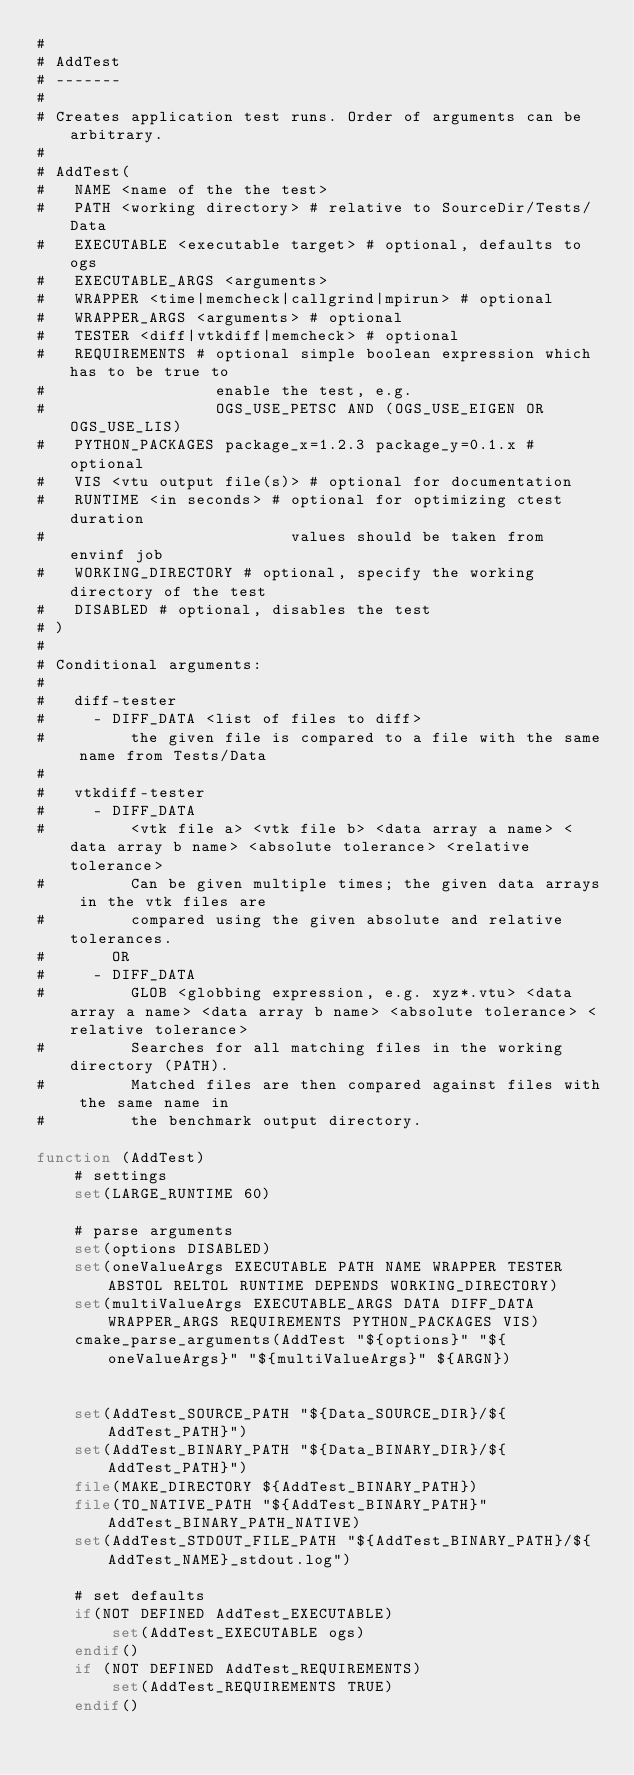<code> <loc_0><loc_0><loc_500><loc_500><_CMake_>#
# AddTest
# -------
#
# Creates application test runs. Order of arguments can be arbitrary.
#
# AddTest(
#   NAME <name of the the test>
#   PATH <working directory> # relative to SourceDir/Tests/Data
#   EXECUTABLE <executable target> # optional, defaults to ogs
#   EXECUTABLE_ARGS <arguments>
#   WRAPPER <time|memcheck|callgrind|mpirun> # optional
#   WRAPPER_ARGS <arguments> # optional
#   TESTER <diff|vtkdiff|memcheck> # optional
#   REQUIREMENTS # optional simple boolean expression which has to be true to
#                  enable the test, e.g.
#                  OGS_USE_PETSC AND (OGS_USE_EIGEN OR OGS_USE_LIS)
#   PYTHON_PACKAGES package_x=1.2.3 package_y=0.1.x # optional
#   VIS <vtu output file(s)> # optional for documentation
#   RUNTIME <in seconds> # optional for optimizing ctest duration
#                          values should be taken from envinf job
#   WORKING_DIRECTORY # optional, specify the working directory of the test
#   DISABLED # optional, disables the test
# )
#
# Conditional arguments:
#
#   diff-tester
#     - DIFF_DATA <list of files to diff>
#         the given file is compared to a file with the same name from Tests/Data
#
#   vtkdiff-tester
#     - DIFF_DATA
#         <vtk file a> <vtk file b> <data array a name> <data array b name> <absolute tolerance> <relative tolerance>
#         Can be given multiple times; the given data arrays in the vtk files are
#         compared using the given absolute and relative tolerances.
#       OR
#     - DIFF_DATA
#         GLOB <globbing expression, e.g. xyz*.vtu> <data array a name> <data array b name> <absolute tolerance> <relative tolerance>
#         Searches for all matching files in the working directory (PATH).
#         Matched files are then compared against files with the same name in
#         the benchmark output directory.

function (AddTest)
    # settings
    set(LARGE_RUNTIME 60)

    # parse arguments
    set(options DISABLED)
    set(oneValueArgs EXECUTABLE PATH NAME WRAPPER TESTER ABSTOL RELTOL RUNTIME DEPENDS WORKING_DIRECTORY)
    set(multiValueArgs EXECUTABLE_ARGS DATA DIFF_DATA WRAPPER_ARGS REQUIREMENTS PYTHON_PACKAGES VIS)
    cmake_parse_arguments(AddTest "${options}" "${oneValueArgs}" "${multiValueArgs}" ${ARGN})


    set(AddTest_SOURCE_PATH "${Data_SOURCE_DIR}/${AddTest_PATH}")
    set(AddTest_BINARY_PATH "${Data_BINARY_DIR}/${AddTest_PATH}")
    file(MAKE_DIRECTORY ${AddTest_BINARY_PATH})
    file(TO_NATIVE_PATH "${AddTest_BINARY_PATH}" AddTest_BINARY_PATH_NATIVE)
    set(AddTest_STDOUT_FILE_PATH "${AddTest_BINARY_PATH}/${AddTest_NAME}_stdout.log")

    # set defaults
    if(NOT DEFINED AddTest_EXECUTABLE)
        set(AddTest_EXECUTABLE ogs)
    endif()
    if (NOT DEFINED AddTest_REQUIREMENTS)
        set(AddTest_REQUIREMENTS TRUE)
    endif()</code> 